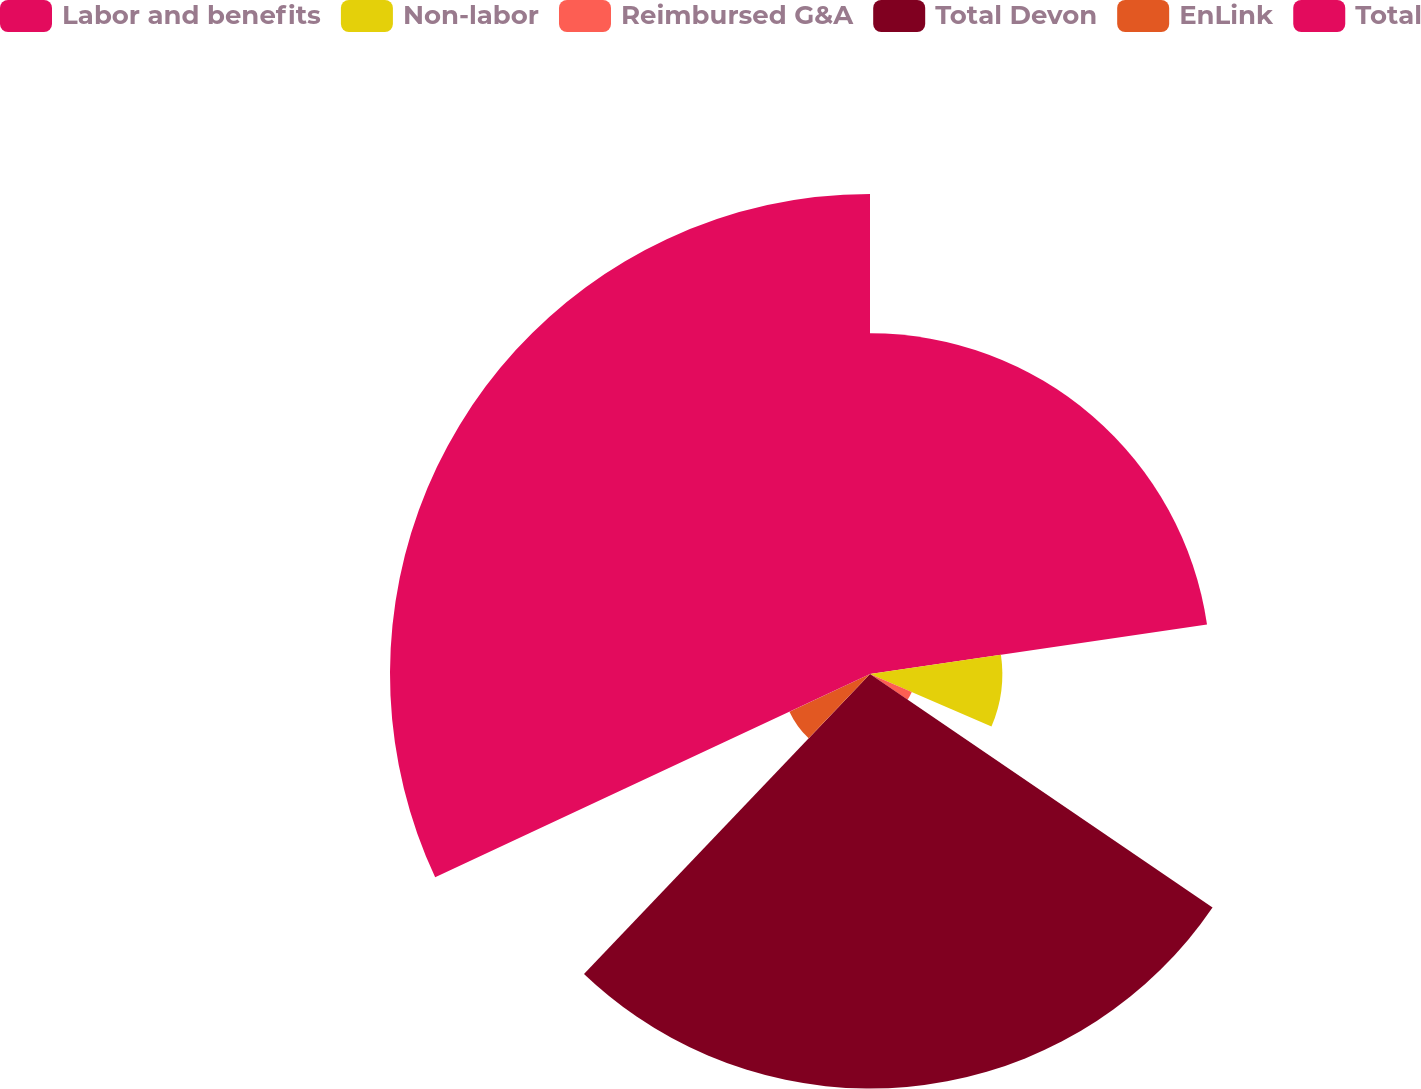<chart> <loc_0><loc_0><loc_500><loc_500><pie_chart><fcel>Labor and benefits<fcel>Non-labor<fcel>Reimbursed G&A<fcel>Total Devon<fcel>EnLink<fcel>Total<nl><fcel>22.68%<fcel>8.81%<fcel>3.03%<fcel>27.6%<fcel>5.92%<fcel>31.96%<nl></chart> 